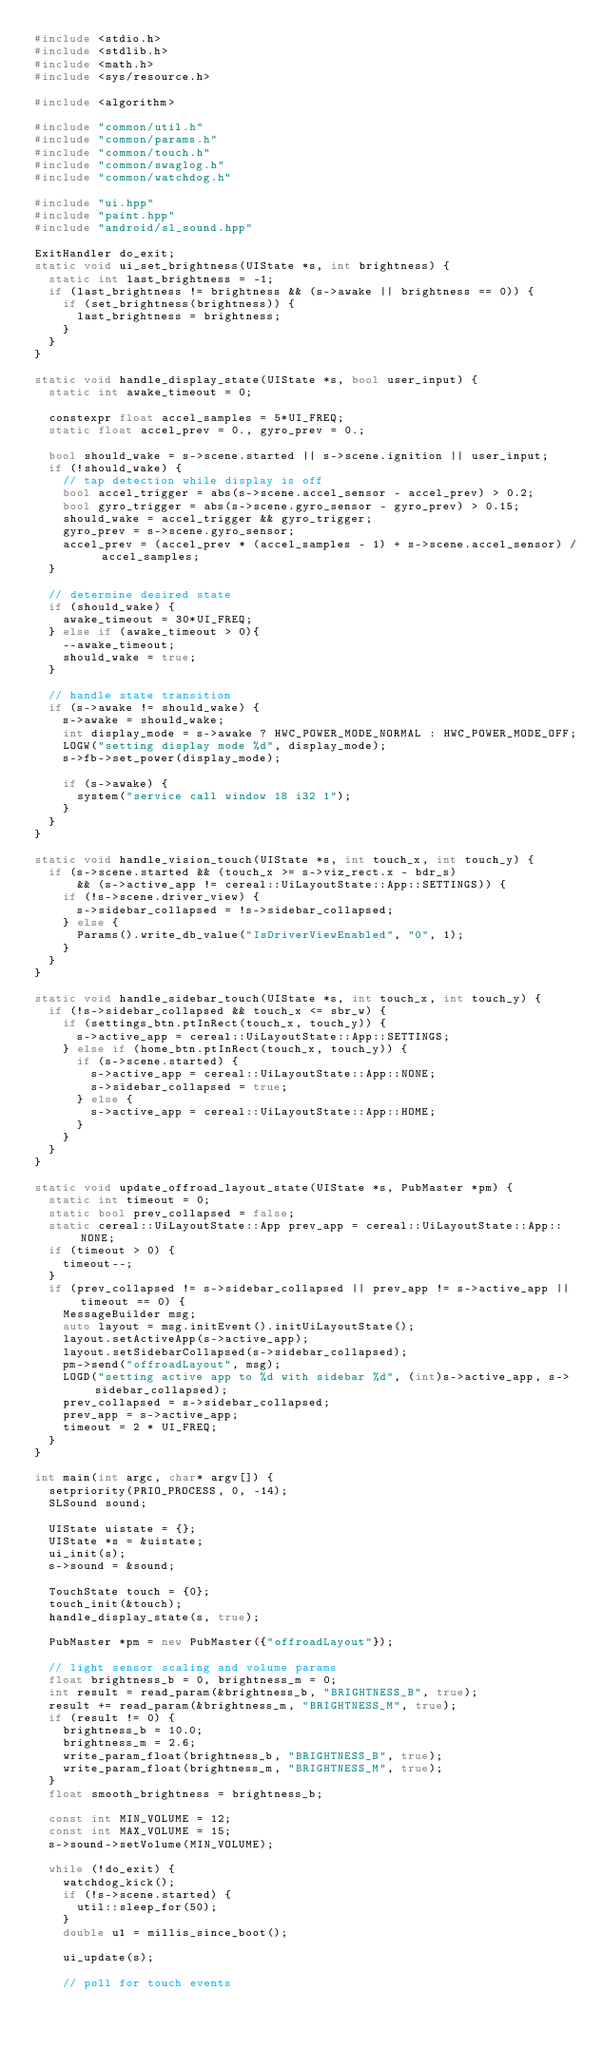<code> <loc_0><loc_0><loc_500><loc_500><_C++_>#include <stdio.h>
#include <stdlib.h>
#include <math.h>
#include <sys/resource.h>

#include <algorithm>

#include "common/util.h"
#include "common/params.h"
#include "common/touch.h"
#include "common/swaglog.h"
#include "common/watchdog.h"

#include "ui.hpp"
#include "paint.hpp"
#include "android/sl_sound.hpp"

ExitHandler do_exit;
static void ui_set_brightness(UIState *s, int brightness) {
  static int last_brightness = -1;
  if (last_brightness != brightness && (s->awake || brightness == 0)) {
    if (set_brightness(brightness)) {
      last_brightness = brightness;
    }
  }
}

static void handle_display_state(UIState *s, bool user_input) {
  static int awake_timeout = 0;

  constexpr float accel_samples = 5*UI_FREQ;
  static float accel_prev = 0., gyro_prev = 0.;

  bool should_wake = s->scene.started || s->scene.ignition || user_input;
  if (!should_wake) {
    // tap detection while display is off
    bool accel_trigger = abs(s->scene.accel_sensor - accel_prev) > 0.2;
    bool gyro_trigger = abs(s->scene.gyro_sensor - gyro_prev) > 0.15;
    should_wake = accel_trigger && gyro_trigger;
    gyro_prev = s->scene.gyro_sensor;
    accel_prev = (accel_prev * (accel_samples - 1) + s->scene.accel_sensor) / accel_samples;
  }

  // determine desired state
  if (should_wake) {
    awake_timeout = 30*UI_FREQ;
  } else if (awake_timeout > 0){
    --awake_timeout;
    should_wake = true;
  }

  // handle state transition
  if (s->awake != should_wake) {
    s->awake = should_wake;
    int display_mode = s->awake ? HWC_POWER_MODE_NORMAL : HWC_POWER_MODE_OFF;
    LOGW("setting display mode %d", display_mode);
    s->fb->set_power(display_mode);

    if (s->awake) {
      system("service call window 18 i32 1");
    }
  }
}

static void handle_vision_touch(UIState *s, int touch_x, int touch_y) {
  if (s->scene.started && (touch_x >= s->viz_rect.x - bdr_s)
      && (s->active_app != cereal::UiLayoutState::App::SETTINGS)) {
    if (!s->scene.driver_view) {
      s->sidebar_collapsed = !s->sidebar_collapsed;
    } else {
      Params().write_db_value("IsDriverViewEnabled", "0", 1);
    }
  }
}

static void handle_sidebar_touch(UIState *s, int touch_x, int touch_y) {
  if (!s->sidebar_collapsed && touch_x <= sbr_w) {
    if (settings_btn.ptInRect(touch_x, touch_y)) {
      s->active_app = cereal::UiLayoutState::App::SETTINGS;
    } else if (home_btn.ptInRect(touch_x, touch_y)) {
      if (s->scene.started) {
        s->active_app = cereal::UiLayoutState::App::NONE;
        s->sidebar_collapsed = true;
      } else {
        s->active_app = cereal::UiLayoutState::App::HOME;
      }
    }
  }
}

static void update_offroad_layout_state(UIState *s, PubMaster *pm) {
  static int timeout = 0;
  static bool prev_collapsed = false;
  static cereal::UiLayoutState::App prev_app = cereal::UiLayoutState::App::NONE;
  if (timeout > 0) {
    timeout--;
  }
  if (prev_collapsed != s->sidebar_collapsed || prev_app != s->active_app || timeout == 0) {
    MessageBuilder msg;
    auto layout = msg.initEvent().initUiLayoutState();
    layout.setActiveApp(s->active_app);
    layout.setSidebarCollapsed(s->sidebar_collapsed);
    pm->send("offroadLayout", msg);
    LOGD("setting active app to %d with sidebar %d", (int)s->active_app, s->sidebar_collapsed);
    prev_collapsed = s->sidebar_collapsed;
    prev_app = s->active_app;
    timeout = 2 * UI_FREQ;
  }
}

int main(int argc, char* argv[]) {
  setpriority(PRIO_PROCESS, 0, -14);
  SLSound sound;

  UIState uistate = {};
  UIState *s = &uistate;
  ui_init(s);
  s->sound = &sound;

  TouchState touch = {0};
  touch_init(&touch);
  handle_display_state(s, true);

  PubMaster *pm = new PubMaster({"offroadLayout"});

  // light sensor scaling and volume params
  float brightness_b = 0, brightness_m = 0;
  int result = read_param(&brightness_b, "BRIGHTNESS_B", true);
  result += read_param(&brightness_m, "BRIGHTNESS_M", true);
  if (result != 0) {
    brightness_b = 10.0;
    brightness_m = 2.6;
    write_param_float(brightness_b, "BRIGHTNESS_B", true);
    write_param_float(brightness_m, "BRIGHTNESS_M", true);
  }
  float smooth_brightness = brightness_b;

  const int MIN_VOLUME = 12;
  const int MAX_VOLUME = 15;
  s->sound->setVolume(MIN_VOLUME);

  while (!do_exit) {
    watchdog_kick();
    if (!s->scene.started) {
      util::sleep_for(50);
    }
    double u1 = millis_since_boot();

    ui_update(s);

    // poll for touch events</code> 